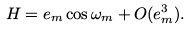Convert formula to latex. <formula><loc_0><loc_0><loc_500><loc_500>H = e _ { m } \cos \omega _ { m } + O ( e _ { m } ^ { 3 } ) .</formula> 